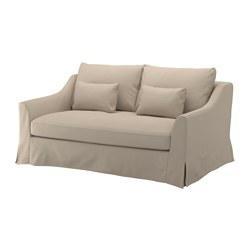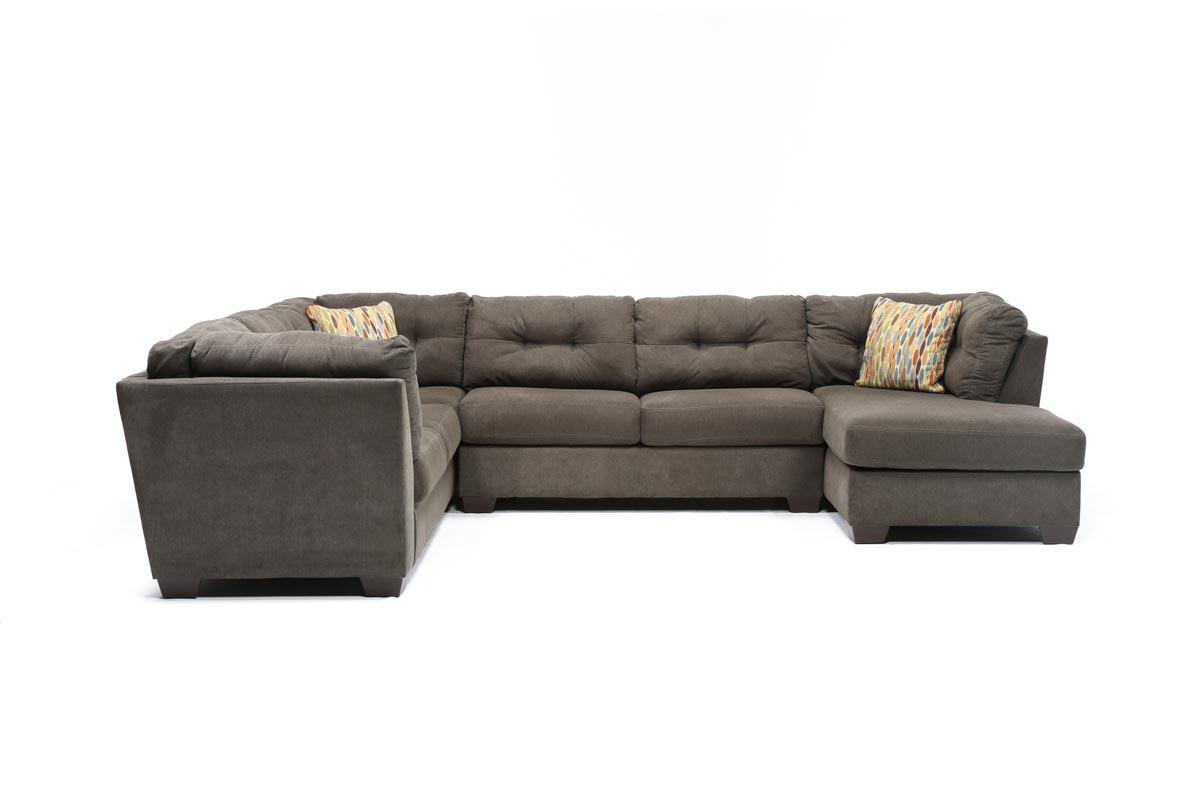The first image is the image on the left, the second image is the image on the right. For the images shown, is this caption "One of the images shows a sectional sofa with an attached ottoman." true? Answer yes or no. Yes. The first image is the image on the left, the second image is the image on the right. Analyze the images presented: Is the assertion "There are a total of 8 throw pillows." valid? Answer yes or no. No. 